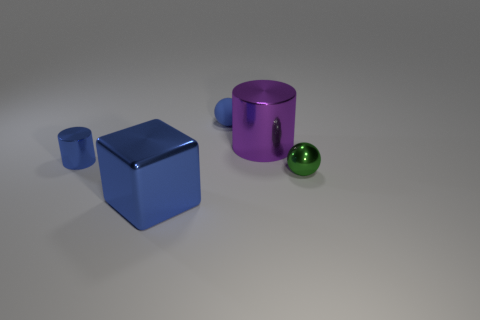Does the tiny green thing have the same shape as the tiny rubber thing?
Offer a very short reply. Yes. What number of small objects are spheres or blue things?
Offer a very short reply. 3. Are there any blue spheres right of the large purple shiny thing?
Provide a short and direct response. No. Is the number of large purple metal things to the right of the large purple shiny thing the same as the number of big brown rubber spheres?
Your answer should be very brief. Yes. What is the size of the purple metallic object that is the same shape as the tiny blue shiny object?
Ensure brevity in your answer.  Large. Does the small blue matte object have the same shape as the tiny metal object that is on the left side of the purple thing?
Your answer should be very brief. No. What size is the sphere that is on the left side of the metallic sphere that is on the right side of the small rubber sphere?
Give a very brief answer. Small. Are there an equal number of cylinders to the left of the large block and tiny balls behind the purple cylinder?
Provide a short and direct response. Yes. The metal thing that is the same shape as the matte object is what color?
Your answer should be compact. Green. How many metal objects are the same color as the big shiny cube?
Your answer should be compact. 1. 